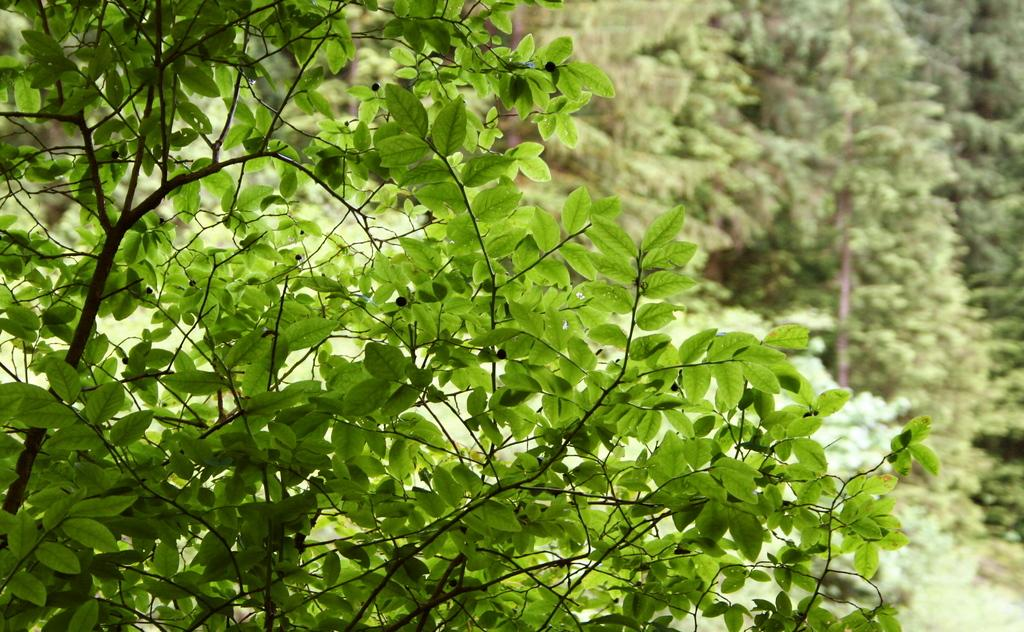What type of plant is visible on the left side of the image? There are green color leaves of a plant on the left side of the image. What can be seen in the background of the image? There are many trees in the background of the image. How many bears can be seen in the image? There are no bears present in the image. 